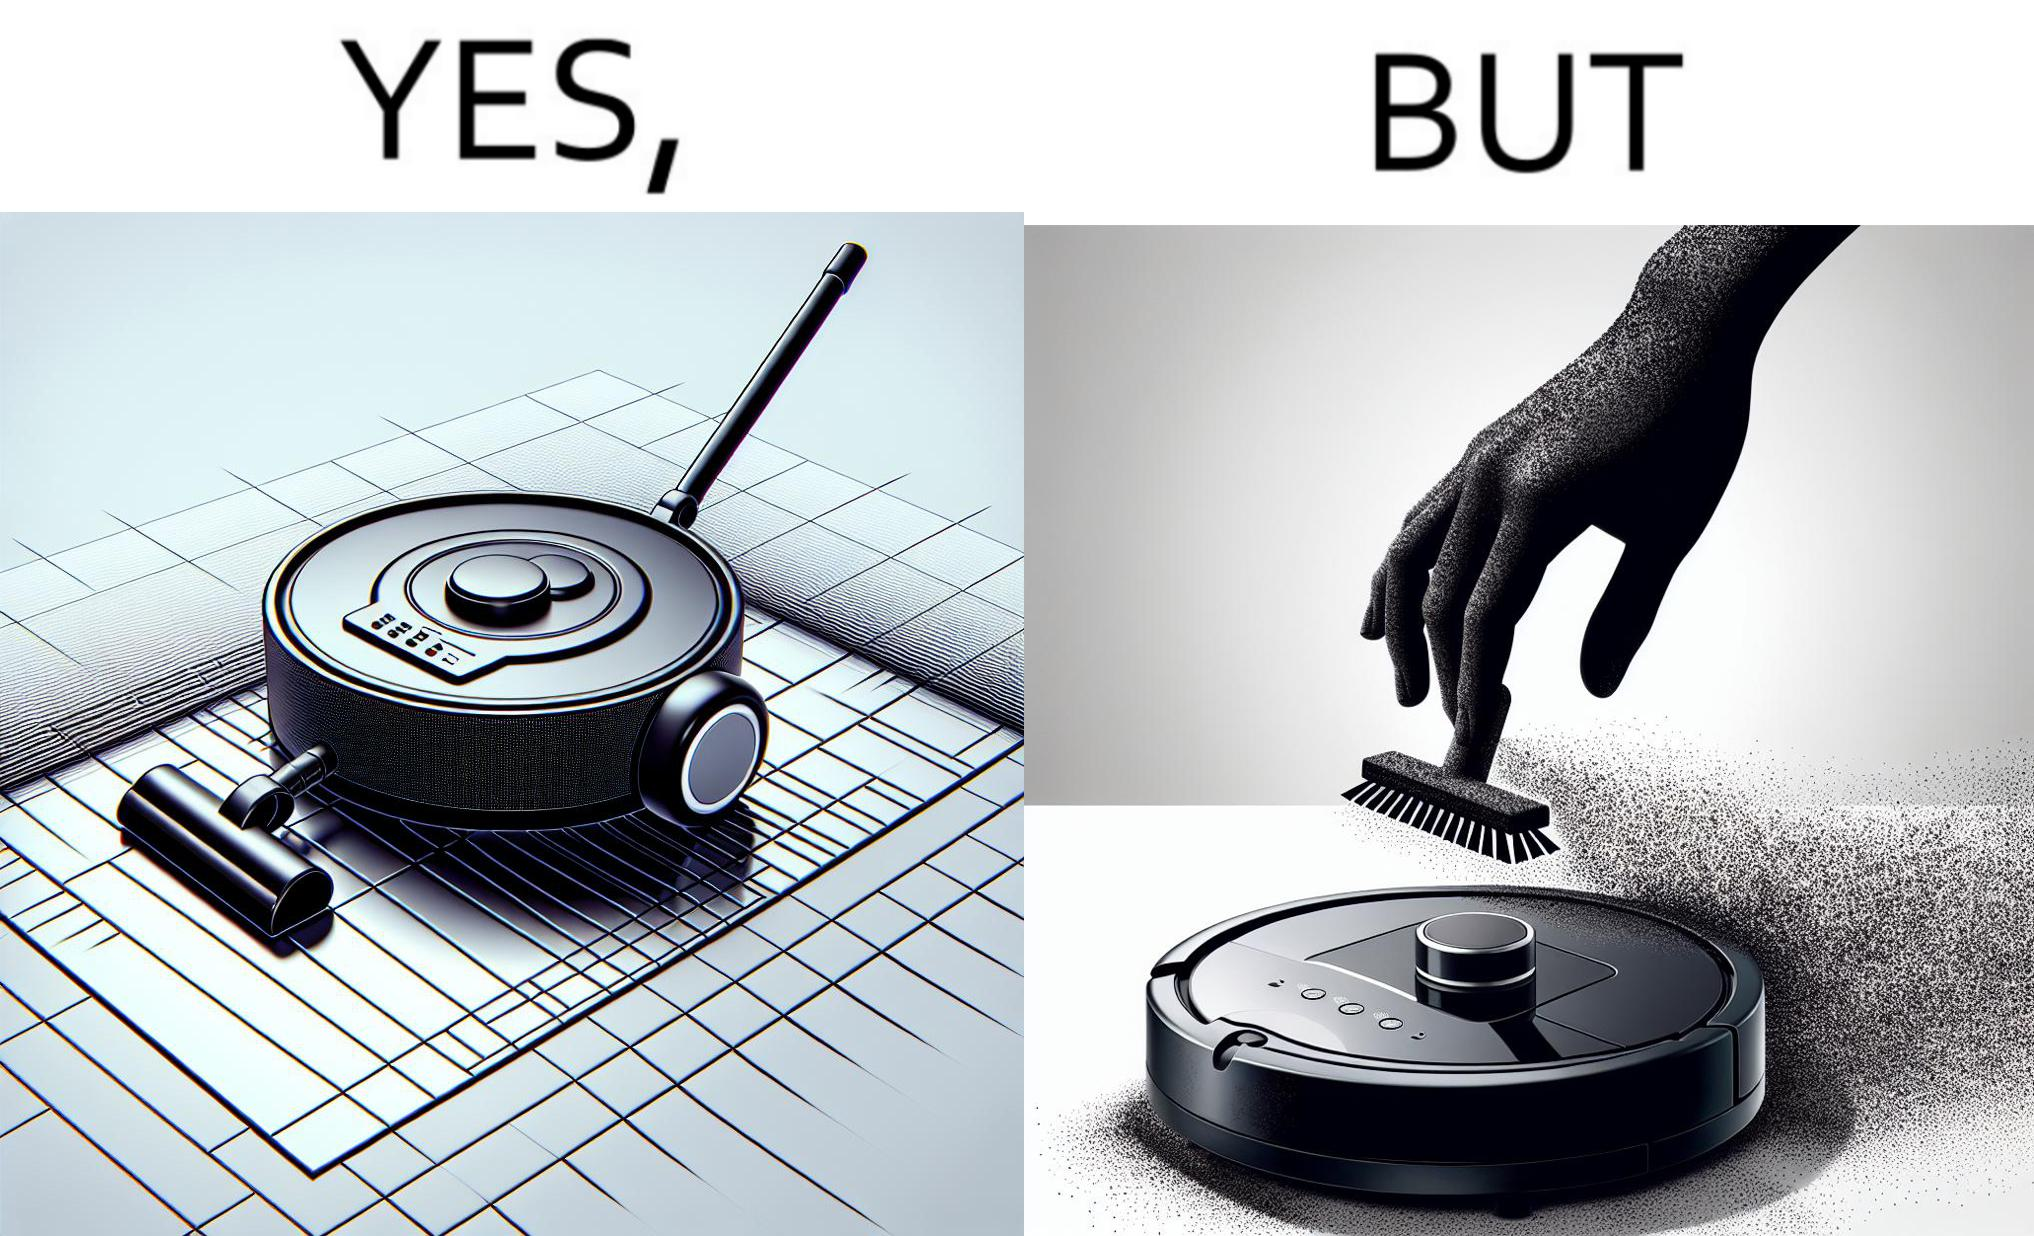Describe the satirical element in this image. This is funny, because the machine while doing its job cleans everything but ends up being dirty itself. 